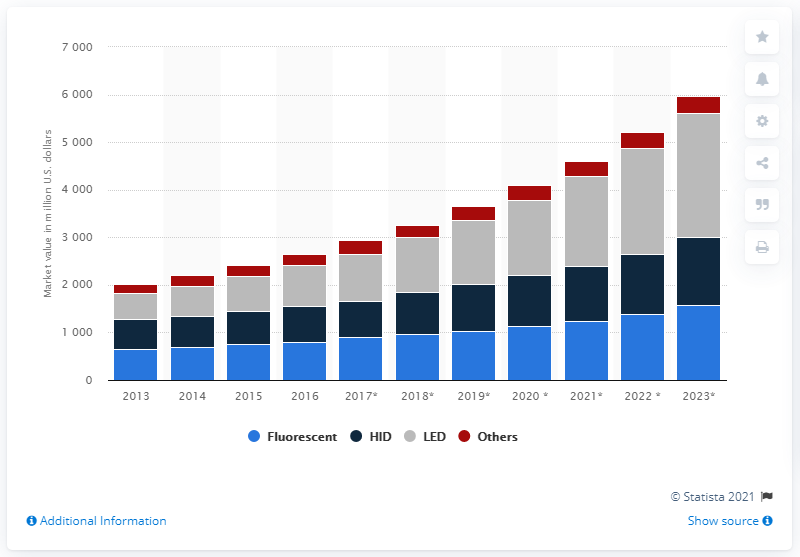Point out several critical features in this image. In 2016, the global market value of fluorescent grow lights was approximately 800 billion U.S. dollars. The global market value of fluorescent grow lights is forecasted to reach 1,580 million US dollars by 2023. 